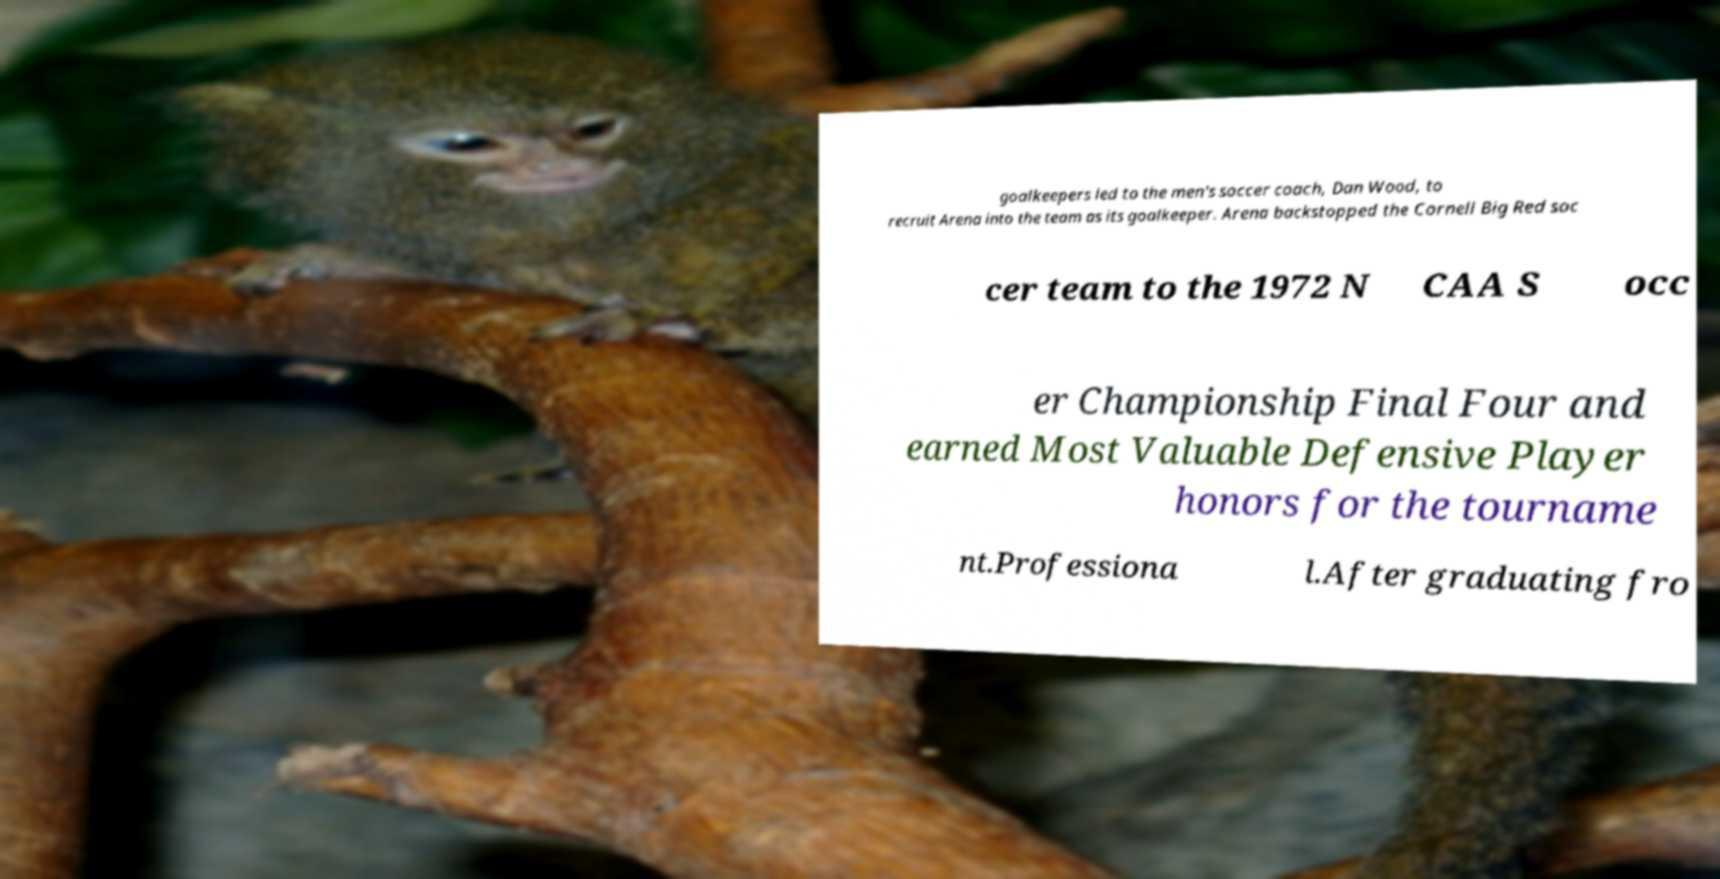Please identify and transcribe the text found in this image. goalkeepers led to the men's soccer coach, Dan Wood, to recruit Arena into the team as its goalkeeper. Arena backstopped the Cornell Big Red soc cer team to the 1972 N CAA S occ er Championship Final Four and earned Most Valuable Defensive Player honors for the tourname nt.Professiona l.After graduating fro 